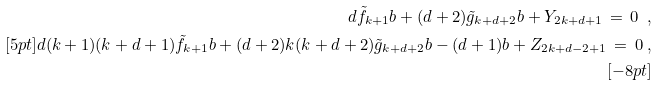Convert formula to latex. <formula><loc_0><loc_0><loc_500><loc_500>d \tilde { f } _ { k + 1 } b + ( d + 2 ) \tilde { g } _ { k + d + 2 } b + Y _ { 2 k + d + 1 } \, = \, 0 \ , \\ [ 5 p t ] d ( k + 1 ) ( k + d + 1 ) \tilde { f } _ { k + 1 } b + ( d + 2 ) k ( k + d + 2 ) \tilde { g } _ { k + d + 2 } b - ( d + 1 ) b + Z _ { 2 k + d - 2 + 1 } \, = \, 0 \ , \\ [ - 8 p t ]</formula> 